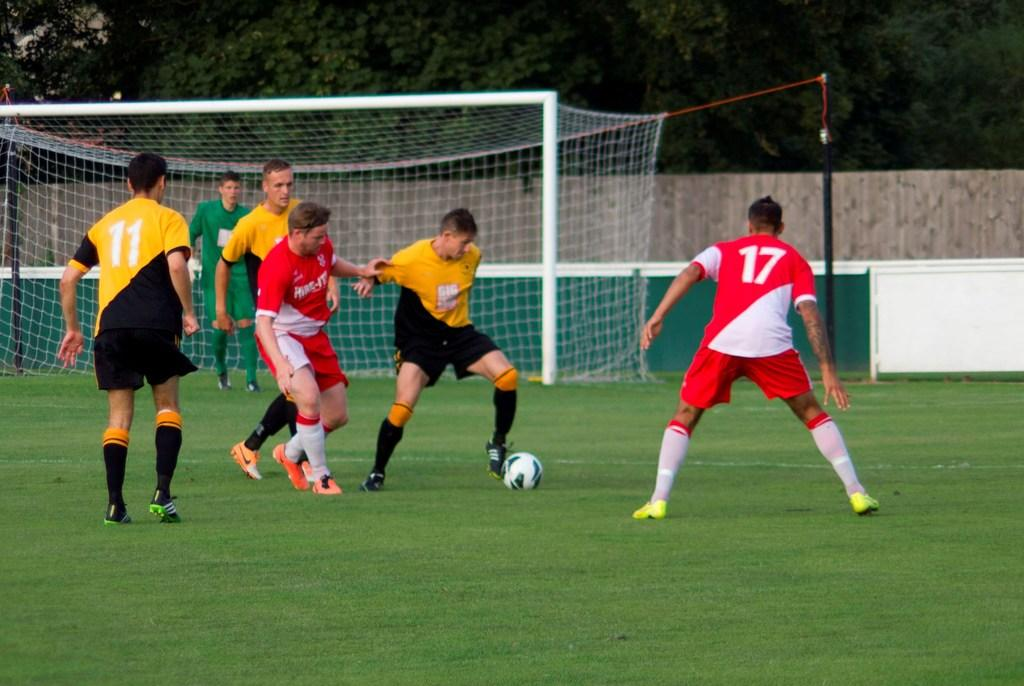<image>
Write a terse but informative summary of the picture. A group of soccer players chase the ball including jersey 17. 